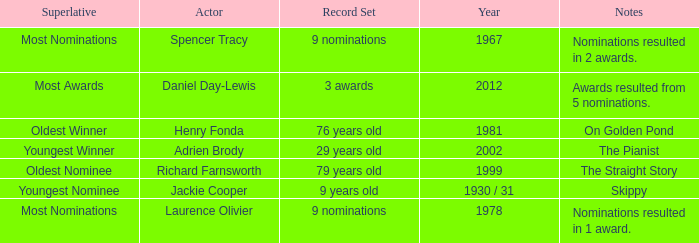What actor won in 1978? Laurence Olivier. 